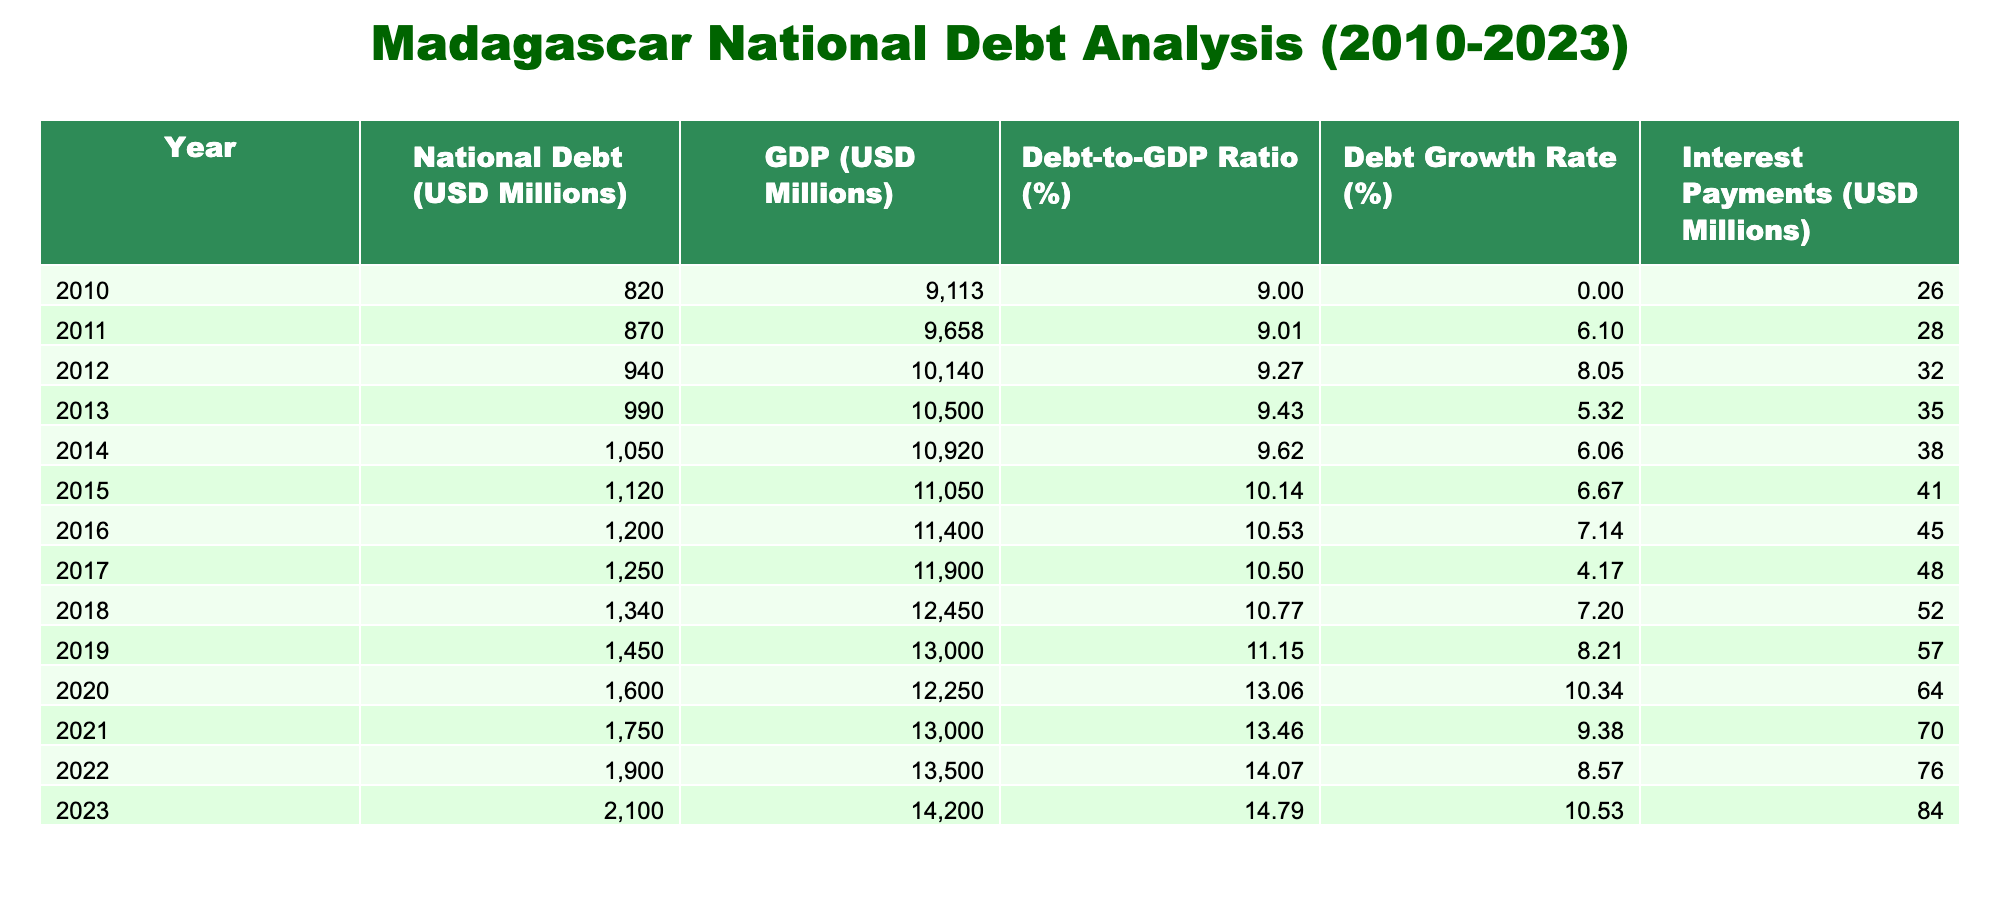What was the National Debt of Madagascar in 2022? The table shows that the National Debt for Madagascar in 2022 is listed as 1900 million USD.
Answer: 1900 million USD What is the Debt-to-GDP ratio for Madagascar in 2019? According to the table, the Debt-to-GDP ratio for Madagascar in 2019 is 11.15%.
Answer: 11.15% What was the total increase in National Debt from 2010 to 2023? The National Debt in 2010 was 820 million USD and in 2023 it is 2100 million USD. Thus, the total increase is 2100 - 820 = 1280 million USD.
Answer: 1280 million USD Was the Debt Growth Rate higher in 2020 compared to 2019? In 2019, the Debt Growth Rate was 8.21% and in 2020 it increased to 10.34%. Therefore, the Debt Growth Rate was indeed higher in 2020 than in 2019.
Answer: Yes What is the average Interest Payments from 2010 to 2023? To calculate the average, we sum all Interest Payments (26 + 28 + 32 + 35 + 38 + 41 + 45 + 48 + 52 + 57 + 64 + 70 + 76 + 84 =  583) and divide by the number of years (14). Thus, the average is 583 / 14 ≈ 41.64 million USD.
Answer: Approximately 41.64 million USD What was the highest Debt-to-GDP ratio recorded during the years shown? The highest Debt-to-GDP ratio appears in 2023 at 14.79%.
Answer: 14.79% How much did Interest Payments increase from 2010 to 2023? Interest Payments increased from 26 million USD in 2010 to 84 million USD in 2023, making the increase 84 - 26 = 58 million USD.
Answer: 58 million USD Did Madagascar's GDP increase continuously from 2010 to 2023? Analyzing the GDP figures from each year, they consistently rise from 9113 million USD in 2010 to 14200 million USD in 2023, indicating continuous growth.
Answer: Yes What is the percentage increase in GDP from 2010 to 2023? The GDP in 2010 was 9113 million USD and in 2023 it is 14200 million USD. The increase is 14200 - 9113 = 5087 million USD. To find the percentage, we calculate (5087 / 9113) * 100 ≈ 55.7%.
Answer: Approximately 55.7% 